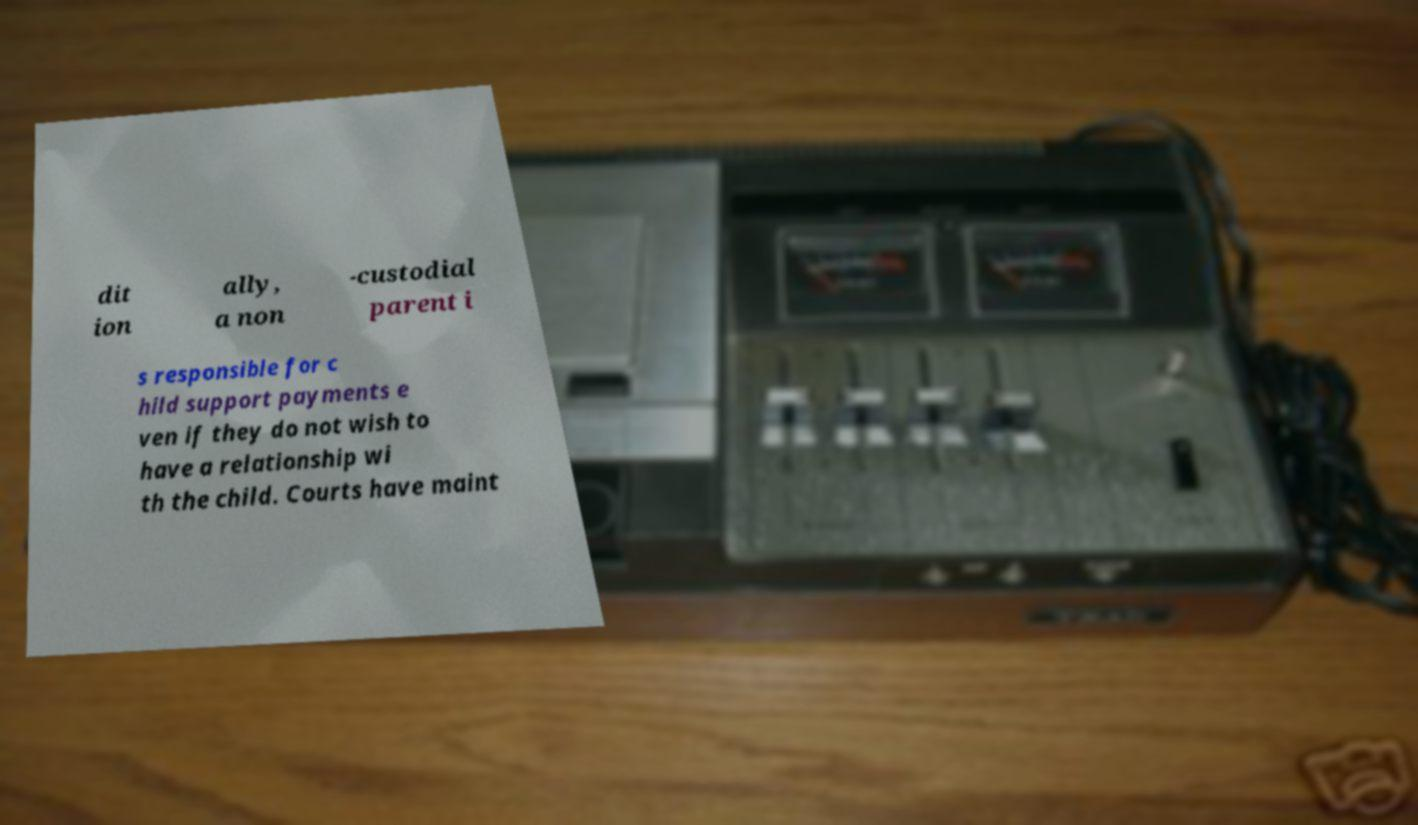For documentation purposes, I need the text within this image transcribed. Could you provide that? dit ion ally, a non -custodial parent i s responsible for c hild support payments e ven if they do not wish to have a relationship wi th the child. Courts have maint 